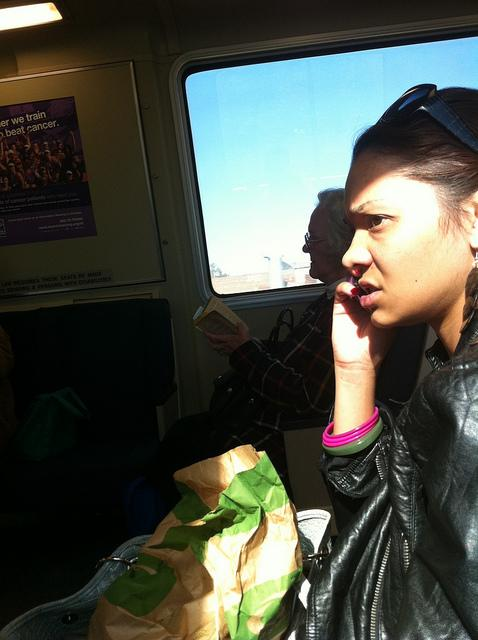What is the brown and green bag made from?

Choices:
A) rubber
B) plastic
C) paper
D) vinyl paper 